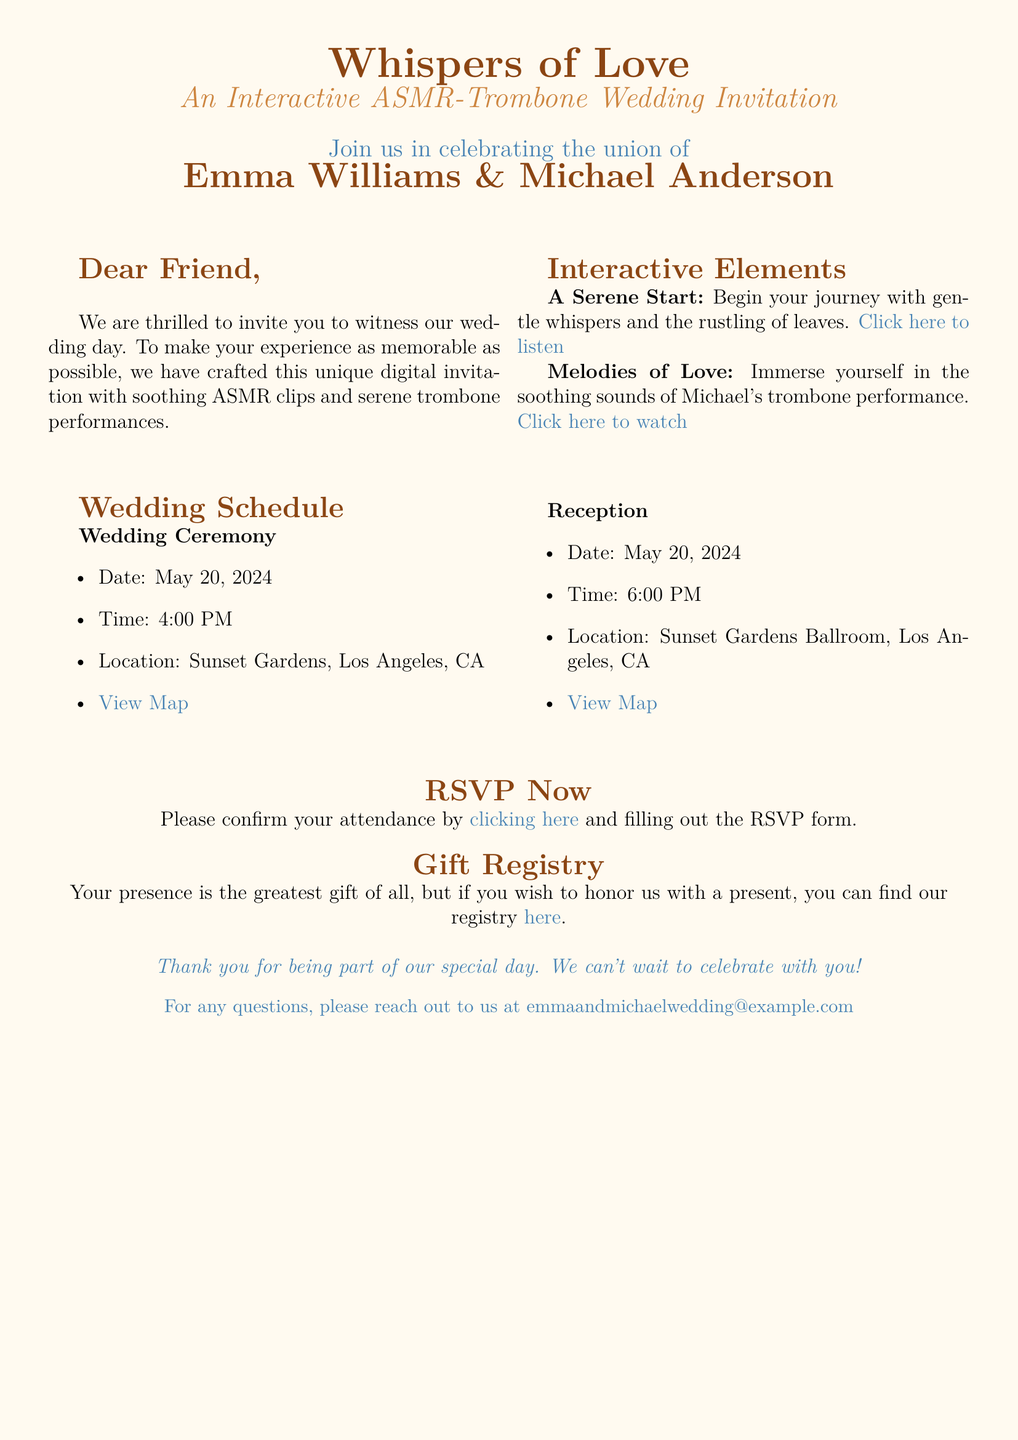What are the names of the couple? The names of the couple are listed prominently in the invitation.
Answer: Emma Williams & Michael Anderson When is the wedding date? The date of the wedding ceremony is specified in the schedule section of the document.
Answer: May 20, 2024 What time does the reception start? The document provides specific timing for both the ceremony and the reception events.
Answer: 6:00 PM Where is the wedding ceremony taking place? The location of the wedding ceremony is provided within the wedding schedule.
Answer: Sunset Gardens, Los Angeles, CA What interactive sound element is mentioned first? The first interactive sound element described in the invitation introduces a serene ASMR experience.
Answer: A Serene Start How can guests RSVP? The invitation specifies a method to confirm attendance through a specific action.
Answer: Clicking here What is the RSVP form link referred to as? The document describes the RSVP link with a specific phrase that prompts action.
Answer: RSVP Now What is highlighted as the greatest gift? The invitation states what the couple values most among the gifts in a specific phrase.
Answer: Your presence What can guests find in the gift registry? The invitation references a specific option for guests who want to give a present.
Answer: Registry 